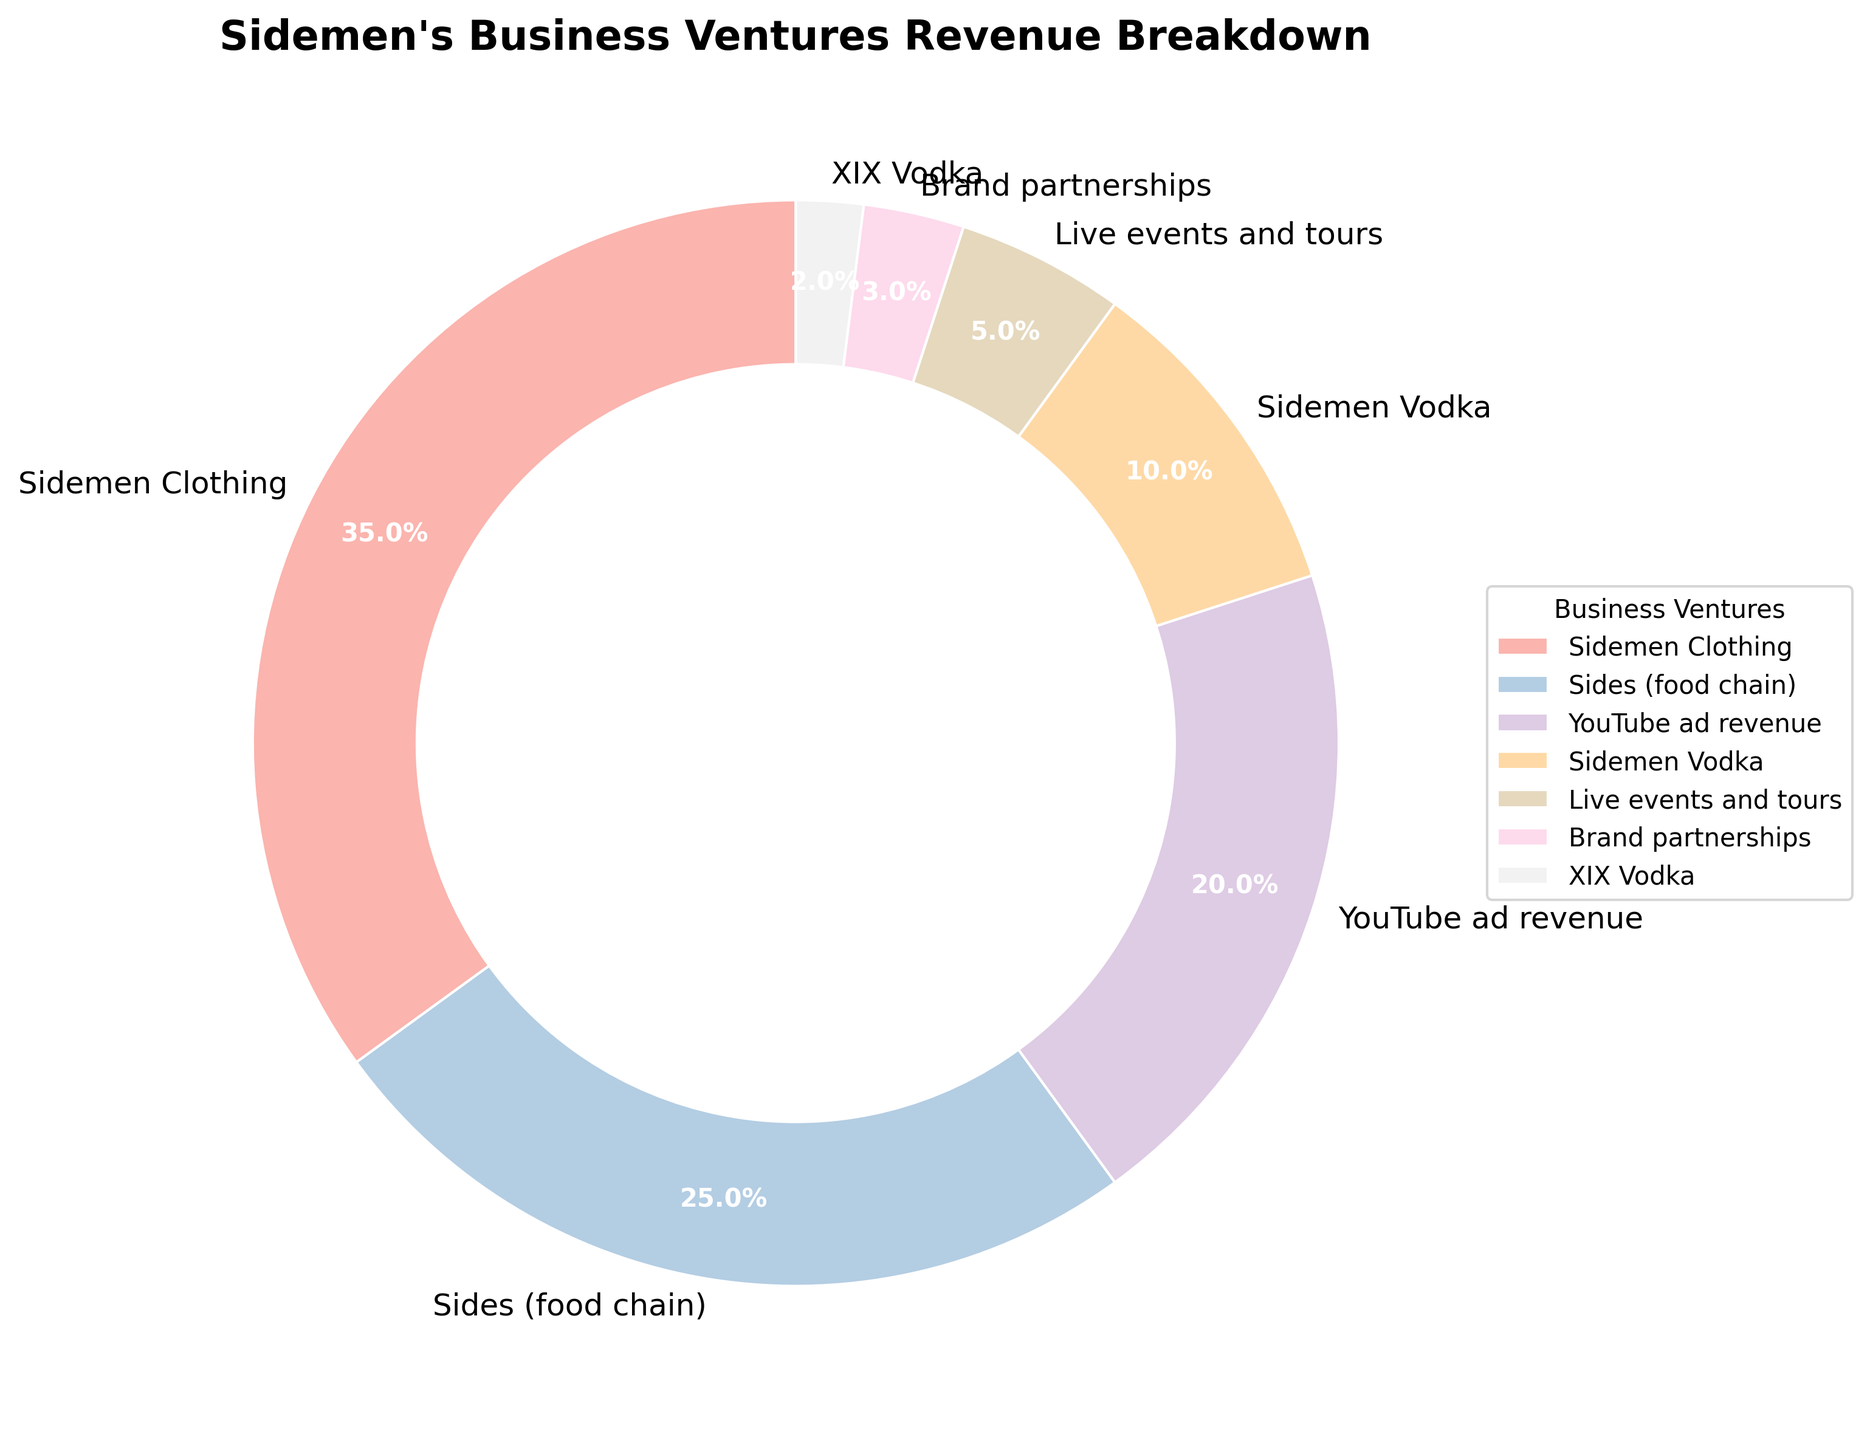What is the revenue percentage of Sidemen Clothing? The pie chart shows the revenue percentages of various business ventures. Sidemen Clothing's section of the pie chart is labeled with its percentage.
Answer: 35% Which business venture has the smallest revenue percentage? By examining the sections of the pie chart, you can identify the business venture with the smallest portion of the pie, which is labeled XIX Vodka.
Answer: XIX Vodka How much greater is the revenue percentage of Sides (food chain) compared to Brand Partnerships? To find this, subtract the percentage of Brand Partnerships from Sides: 25% (Sides) - 3% (Brand Partnerships) = 22%.
Answer: 22% What is the combined revenue percentage of Sidemen Vodka and XIX Vodka? Add the percentages of Sidemen Vodka and XIX Vodka together: 10% (Sidemen Vodka) + 2% (XIX Vodka) = 12%.
Answer: 12% Which two business ventures together make up half of the total revenue? Look for two ventures that sum up to 50%. Sidemen Clothing and Sides (food chain) together form 35% + 25% = 60%, but Sidemen Clothing and YouTube ad revenue form 35% + 20% = 55%, which is closer. However, no combination exactly equals 50%. The nearest close combination making up half is Sidemen Clothing and YouTube ad revenue (55%) or Sidemen Clothing and Sides (60%). If exactly half is required, it's not possible from given data.
Answer: No exact match, closest is Sidemen Clothing and YouTube ad revenue (55%) Which segment of the pie chart appears to be visually the largest in size? By looking at the visual distribution in the pie chart, the segment for Sidemen Clothing is the largest.
Answer: Sidemen Clothing If the segments representing Live events and tours and YouTube ad revenue were combined, would the combined segment be greater than the Sides (food chain) segment? Add the percentages of Live events and tours and YouTube ad revenue, and compare the result to the percentage for the Sides (food chain). 5% (Live events and tours) + 20% (YouTube ad revenue) = 25%, which is equal to Sides (food chain). Hence, it's not greater.
Answer: No, it equals Sides (25%) In terms of revenue percentage, is Sidemen Vodka more than double of brand partnerships? Double the Brand Partnerships' percentage and compare it with Sidemen Vodka. Double of 3% is 6%, which is less than Sidemen Vodka's 10%.
Answer: Yes Which business venture, when combined with the revenue from Sidemen Vodka, gets closest to one-third of the total? First, find one-third of 100%, which is about 33.33%. Then, add Sidemen Vodka's percentage (10%) to the other ventures: the closest combination without exceeding one-third is combining Sidemen Vodka (10%) with Sides (food chain) (25%): 10% + 25% = 35%.
Answer: Sidemen Vodka and Sides 